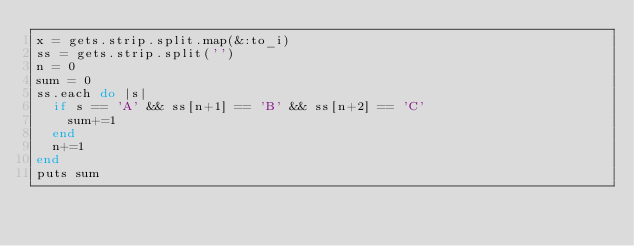<code> <loc_0><loc_0><loc_500><loc_500><_Ruby_>x = gets.strip.split.map(&:to_i)
ss = gets.strip.split('')
n = 0
sum = 0
ss.each do |s|
  if s == 'A' && ss[n+1] == 'B' && ss[n+2] == 'C'
    sum+=1
  end
  n+=1
end
puts sum
</code> 